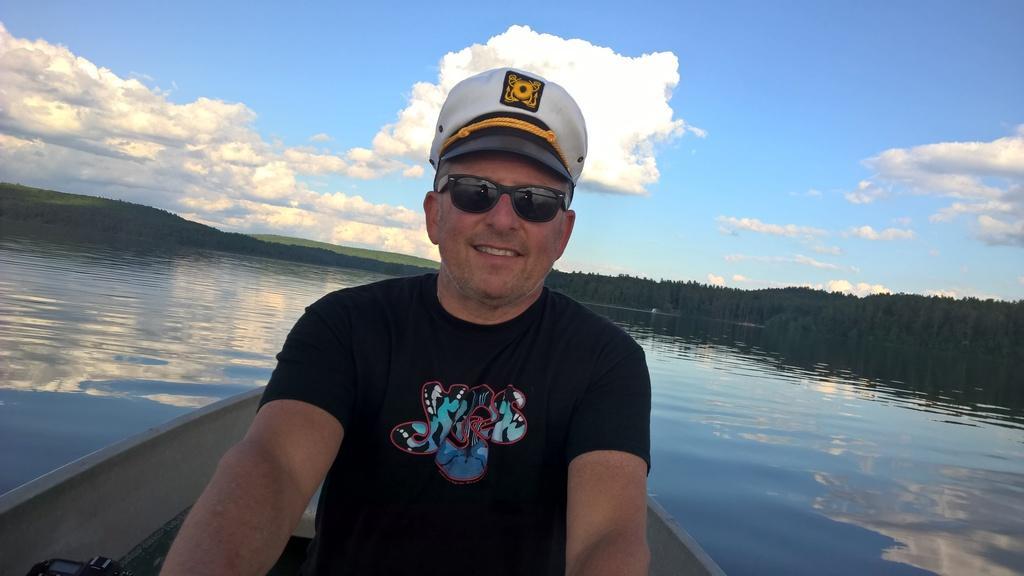How would you summarize this image in a sentence or two? In the center of the image, we can see a man on the boat and wearing a cap on his head. In the background, we can see trees and hills. At the bottom, there is water and at the top, there are clouds in the sky. 